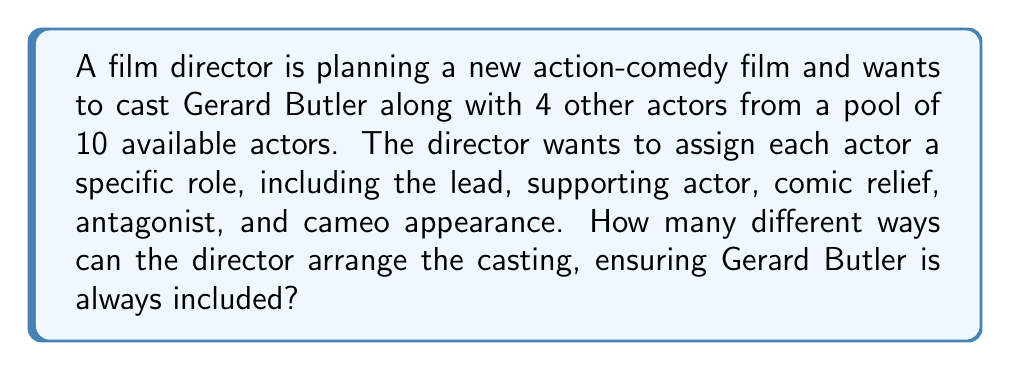Could you help me with this problem? Let's approach this problem step-by-step using permutation groups:

1) First, we need to consider that Gerard Butler must be included in the cast. This means we're essentially selecting 4 more actors from the remaining 9.

2) We can use the combination formula to calculate how many ways we can select 4 actors from 9:

   $$\binom{9}{4} = \frac{9!}{4!(9-4)!} = \frac{9!}{4!5!} = 126$$

3) Now, we have Gerard Butler and 4 other selected actors. We need to arrange these 5 actors into the 5 specific roles.

4) This is a permutation problem. The number of ways to arrange 5 actors into 5 roles is:

   $$5! = 5 \times 4 \times 3 \times 2 \times 1 = 120$$

5) By the multiplication principle, the total number of possible casting arrangements is the product of the number of ways to select the 4 additional actors and the number of ways to arrange all 5 actors:

   $$126 \times 120 = 15,120$$

This result represents the order of the permutation group for this casting scenario.
Answer: There are 15,120 different ways to arrange the casting. 